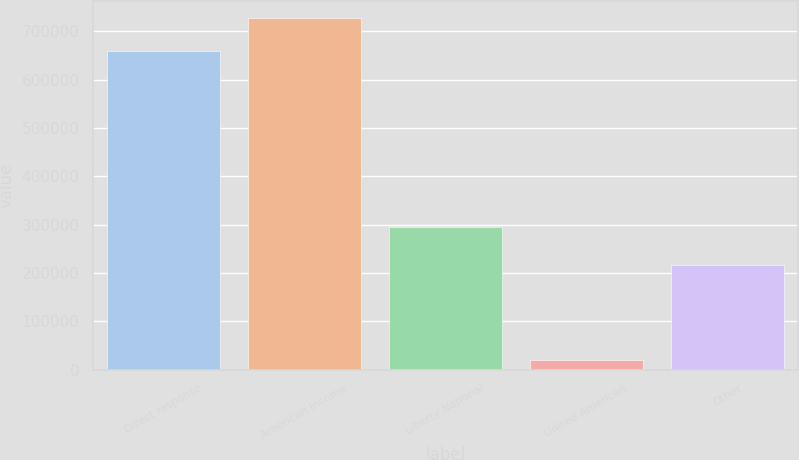<chart> <loc_0><loc_0><loc_500><loc_500><bar_chart><fcel>Direct response<fcel>American Income<fcel>Liberty National<fcel>United American<fcel>Other<nl><fcel>659026<fcel>727614<fcel>295396<fcel>19533<fcel>215645<nl></chart> 